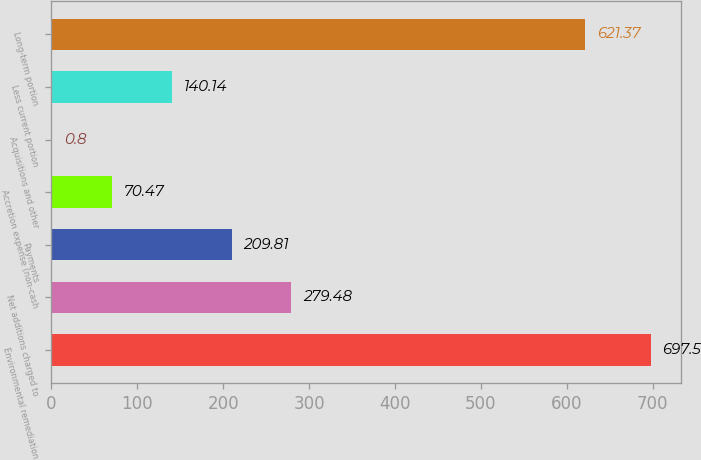<chart> <loc_0><loc_0><loc_500><loc_500><bar_chart><fcel>Environmental remediation<fcel>Net additions charged to<fcel>Payments<fcel>Accretion expense (non-cash<fcel>Acquisitions and other<fcel>Less current portion<fcel>Long-term portion<nl><fcel>697.5<fcel>279.48<fcel>209.81<fcel>70.47<fcel>0.8<fcel>140.14<fcel>621.37<nl></chart> 